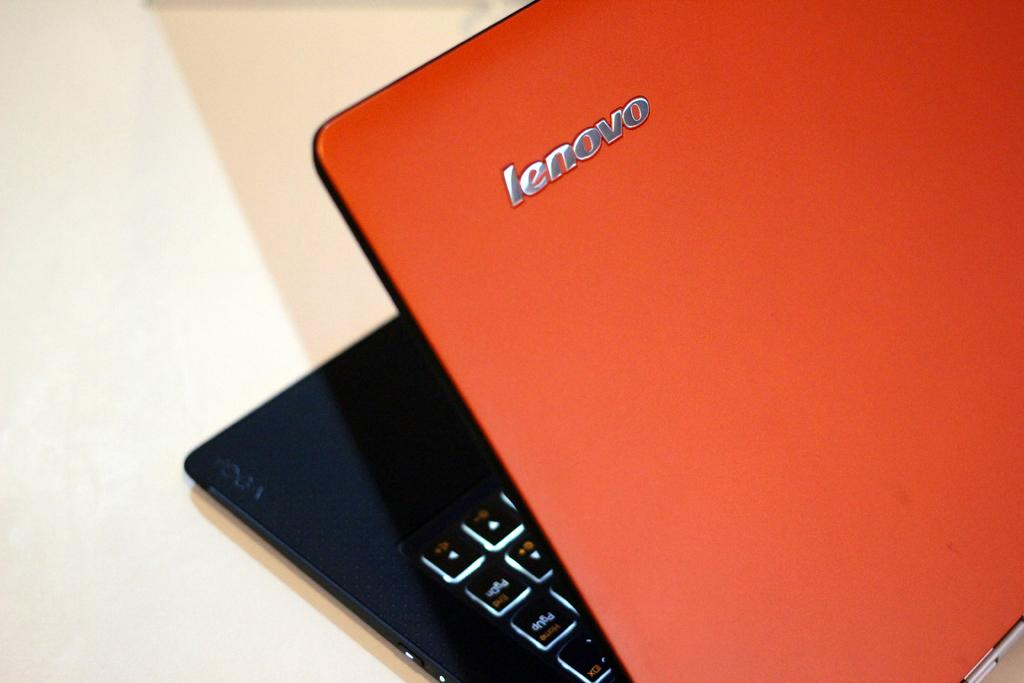<image>
Create a compact narrative representing the image presented. A lenovo laptop has an orange cover and a black keyboard. 